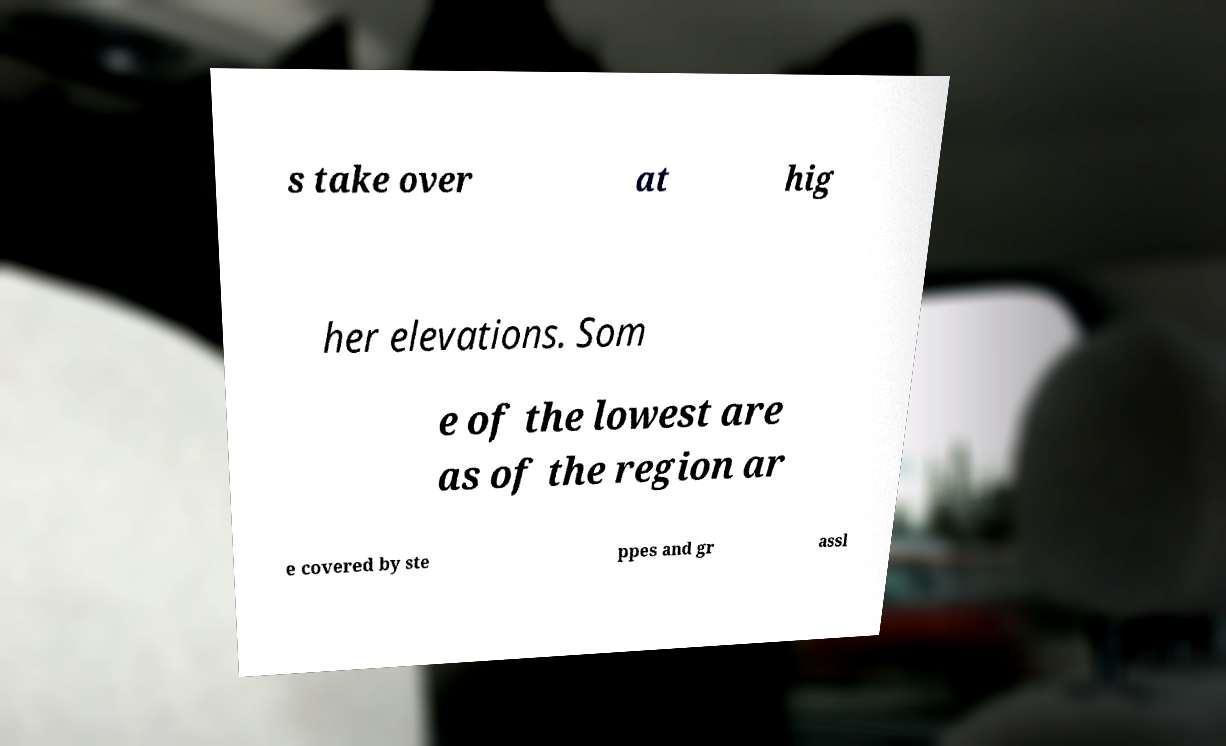I need the written content from this picture converted into text. Can you do that? s take over at hig her elevations. Som e of the lowest are as of the region ar e covered by ste ppes and gr assl 